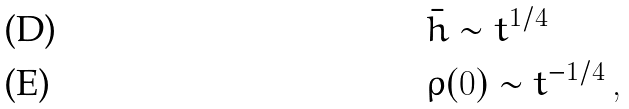<formula> <loc_0><loc_0><loc_500><loc_500>& \bar { h } \sim t ^ { 1 / 4 } \\ & \rho ( 0 ) \sim t ^ { - 1 / 4 } \, ,</formula> 